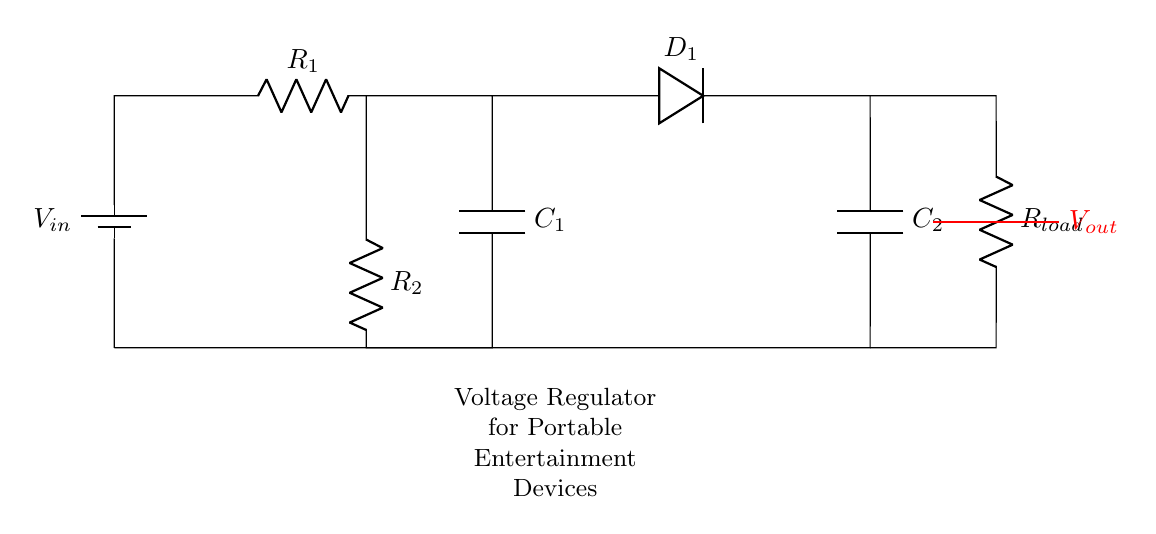What is the role of C1 in this circuit? C1 acts as a smoothing capacitor that helps to reduce voltage ripple by storing charge and releasing it when needed, smoothing the output power supply.
Answer: Smoothing capacitor What is the function of D1 in this circuit? D1 is a diode that allows current to flow only in one direction, providing rectification and preventing reverse current that could damage the circuit.
Answer: Rectification How many resistors are in the diagram? There are two resistors present in this circuit; R1 and R2 are the two components identified as resistors.
Answer: Two What does Vout represent? Vout represents the output voltage of the circuit, which is the stable voltage supplied to the load connected at the end of the circuit.
Answer: Output voltage What is the purpose of the RC elements in this circuit? The RC elements, comprising resistors and capacitors, work together to filter and stabilize the voltage output, ensuring stable power supply to the attached devices.
Answer: Filter and stabilize voltage How does increasing R1 affect the circuit? Increasing R1 will reduce the current flowing through the circuit, potentially affecting the voltage drop across it and the charging time of C1, which affects output stability.
Answer: Reduces current 